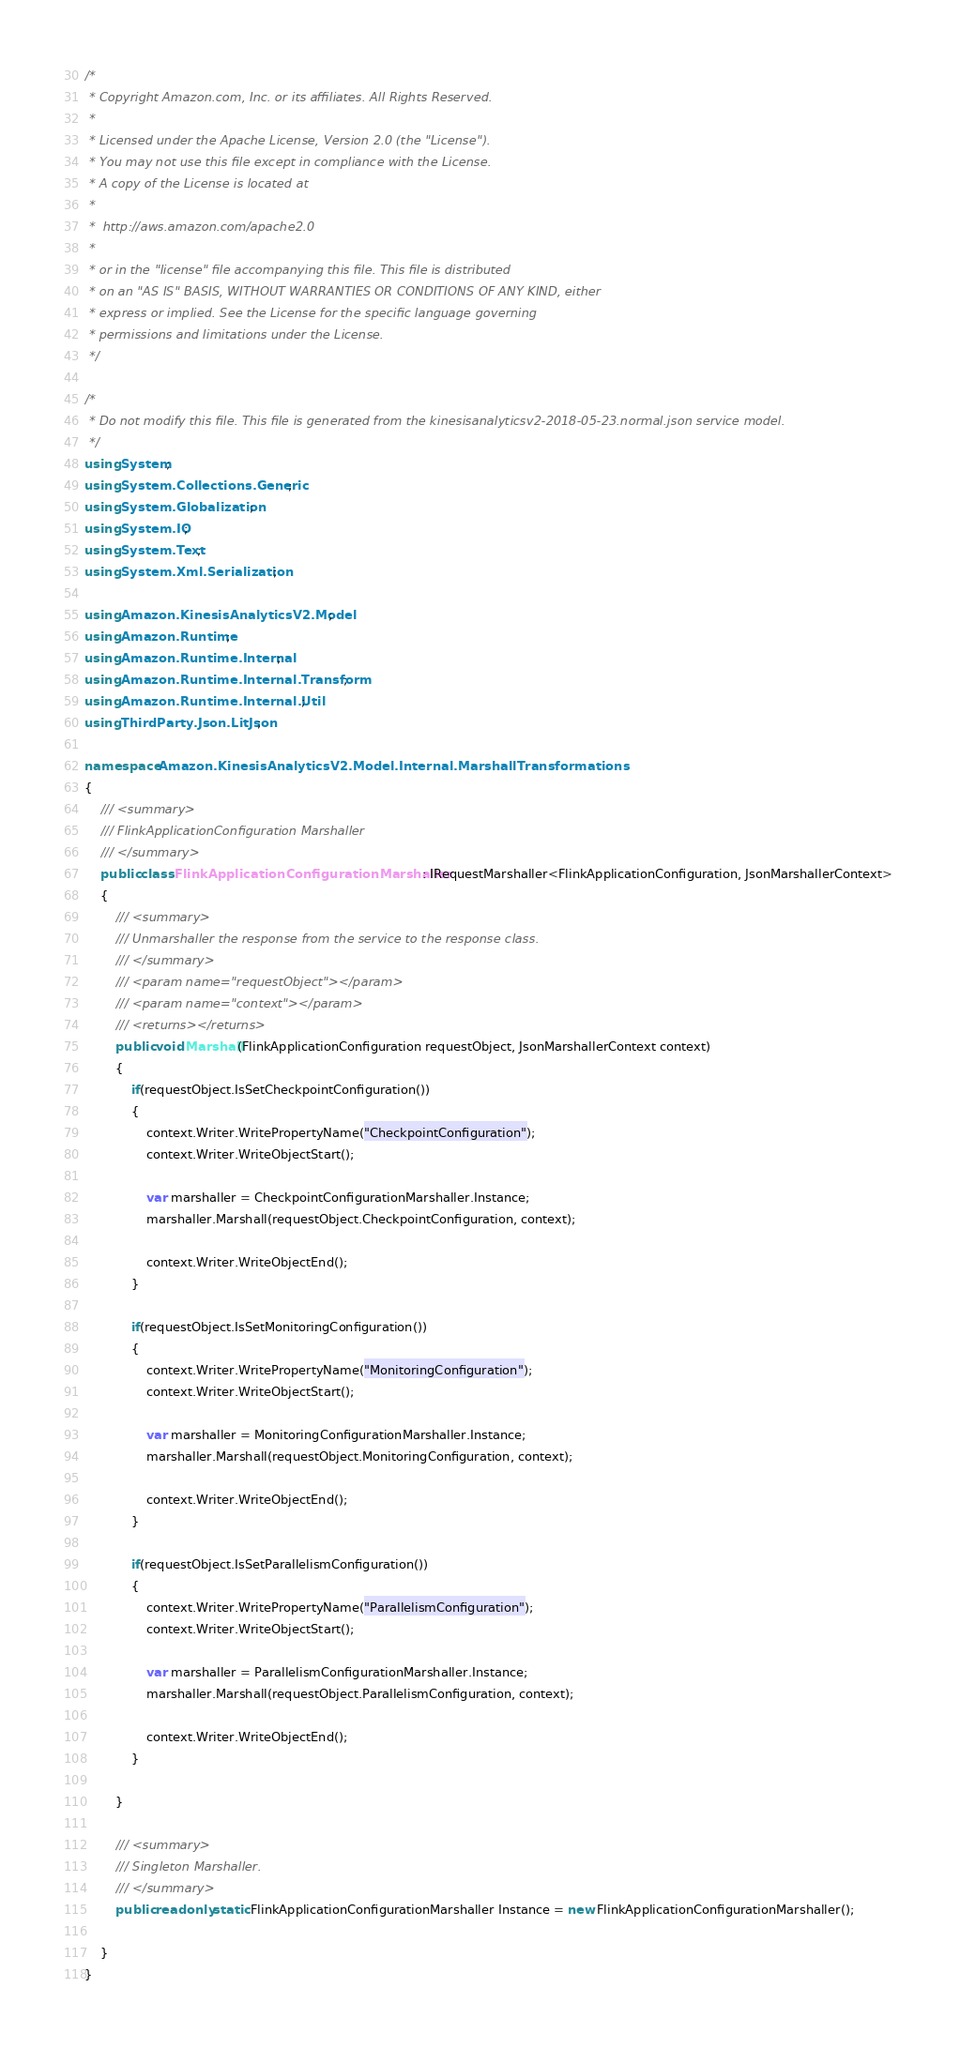<code> <loc_0><loc_0><loc_500><loc_500><_C#_>/*
 * Copyright Amazon.com, Inc. or its affiliates. All Rights Reserved.
 * 
 * Licensed under the Apache License, Version 2.0 (the "License").
 * You may not use this file except in compliance with the License.
 * A copy of the License is located at
 * 
 *  http://aws.amazon.com/apache2.0
 * 
 * or in the "license" file accompanying this file. This file is distributed
 * on an "AS IS" BASIS, WITHOUT WARRANTIES OR CONDITIONS OF ANY KIND, either
 * express or implied. See the License for the specific language governing
 * permissions and limitations under the License.
 */

/*
 * Do not modify this file. This file is generated from the kinesisanalyticsv2-2018-05-23.normal.json service model.
 */
using System;
using System.Collections.Generic;
using System.Globalization;
using System.IO;
using System.Text;
using System.Xml.Serialization;

using Amazon.KinesisAnalyticsV2.Model;
using Amazon.Runtime;
using Amazon.Runtime.Internal;
using Amazon.Runtime.Internal.Transform;
using Amazon.Runtime.Internal.Util;
using ThirdParty.Json.LitJson;

namespace Amazon.KinesisAnalyticsV2.Model.Internal.MarshallTransformations
{
    /// <summary>
    /// FlinkApplicationConfiguration Marshaller
    /// </summary>       
    public class FlinkApplicationConfigurationMarshaller : IRequestMarshaller<FlinkApplicationConfiguration, JsonMarshallerContext> 
    {
        /// <summary>
        /// Unmarshaller the response from the service to the response class.
        /// </summary>  
        /// <param name="requestObject"></param>
        /// <param name="context"></param>
        /// <returns></returns>
        public void Marshall(FlinkApplicationConfiguration requestObject, JsonMarshallerContext context)
        {
            if(requestObject.IsSetCheckpointConfiguration())
            {
                context.Writer.WritePropertyName("CheckpointConfiguration");
                context.Writer.WriteObjectStart();

                var marshaller = CheckpointConfigurationMarshaller.Instance;
                marshaller.Marshall(requestObject.CheckpointConfiguration, context);

                context.Writer.WriteObjectEnd();
            }

            if(requestObject.IsSetMonitoringConfiguration())
            {
                context.Writer.WritePropertyName("MonitoringConfiguration");
                context.Writer.WriteObjectStart();

                var marshaller = MonitoringConfigurationMarshaller.Instance;
                marshaller.Marshall(requestObject.MonitoringConfiguration, context);

                context.Writer.WriteObjectEnd();
            }

            if(requestObject.IsSetParallelismConfiguration())
            {
                context.Writer.WritePropertyName("ParallelismConfiguration");
                context.Writer.WriteObjectStart();

                var marshaller = ParallelismConfigurationMarshaller.Instance;
                marshaller.Marshall(requestObject.ParallelismConfiguration, context);

                context.Writer.WriteObjectEnd();
            }

        }

        /// <summary>
        /// Singleton Marshaller.
        /// </summary>  
        public readonly static FlinkApplicationConfigurationMarshaller Instance = new FlinkApplicationConfigurationMarshaller();

    }
}</code> 